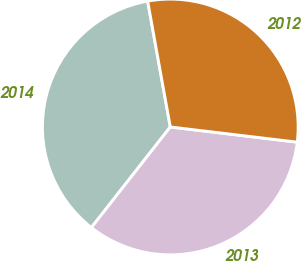Convert chart. <chart><loc_0><loc_0><loc_500><loc_500><pie_chart><fcel>2014<fcel>2013<fcel>2012<nl><fcel>36.58%<fcel>33.69%<fcel>29.73%<nl></chart> 